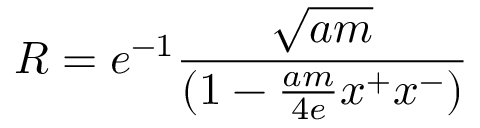Convert formula to latex. <formula><loc_0><loc_0><loc_500><loc_500>R = e ^ { - 1 } { \frac { \sqrt { a m } } { ( 1 - { \frac { a m } { 4 e } } x ^ { + } x ^ { - } ) } }</formula> 